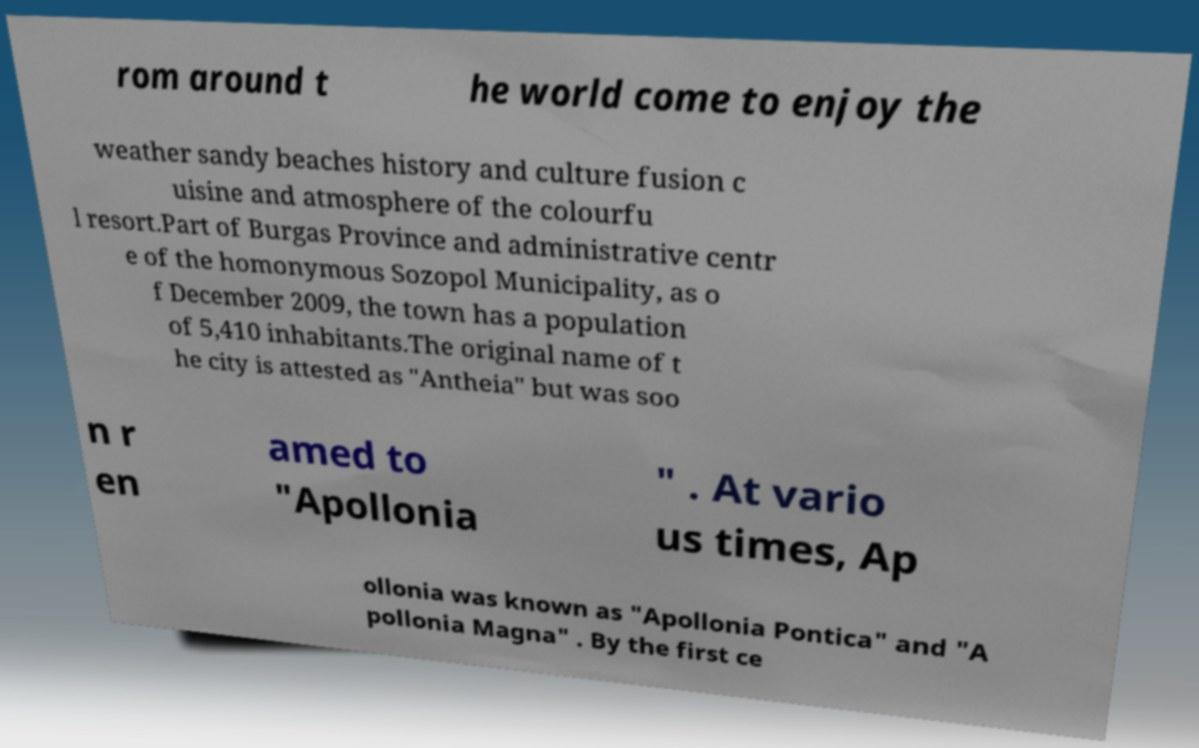Can you accurately transcribe the text from the provided image for me? rom around t he world come to enjoy the weather sandy beaches history and culture fusion c uisine and atmosphere of the colourfu l resort.Part of Burgas Province and administrative centr e of the homonymous Sozopol Municipality, as o f December 2009, the town has a population of 5,410 inhabitants.The original name of t he city is attested as "Antheia" but was soo n r en amed to "Apollonia " . At vario us times, Ap ollonia was known as "Apollonia Pontica" and "A pollonia Magna" . By the first ce 